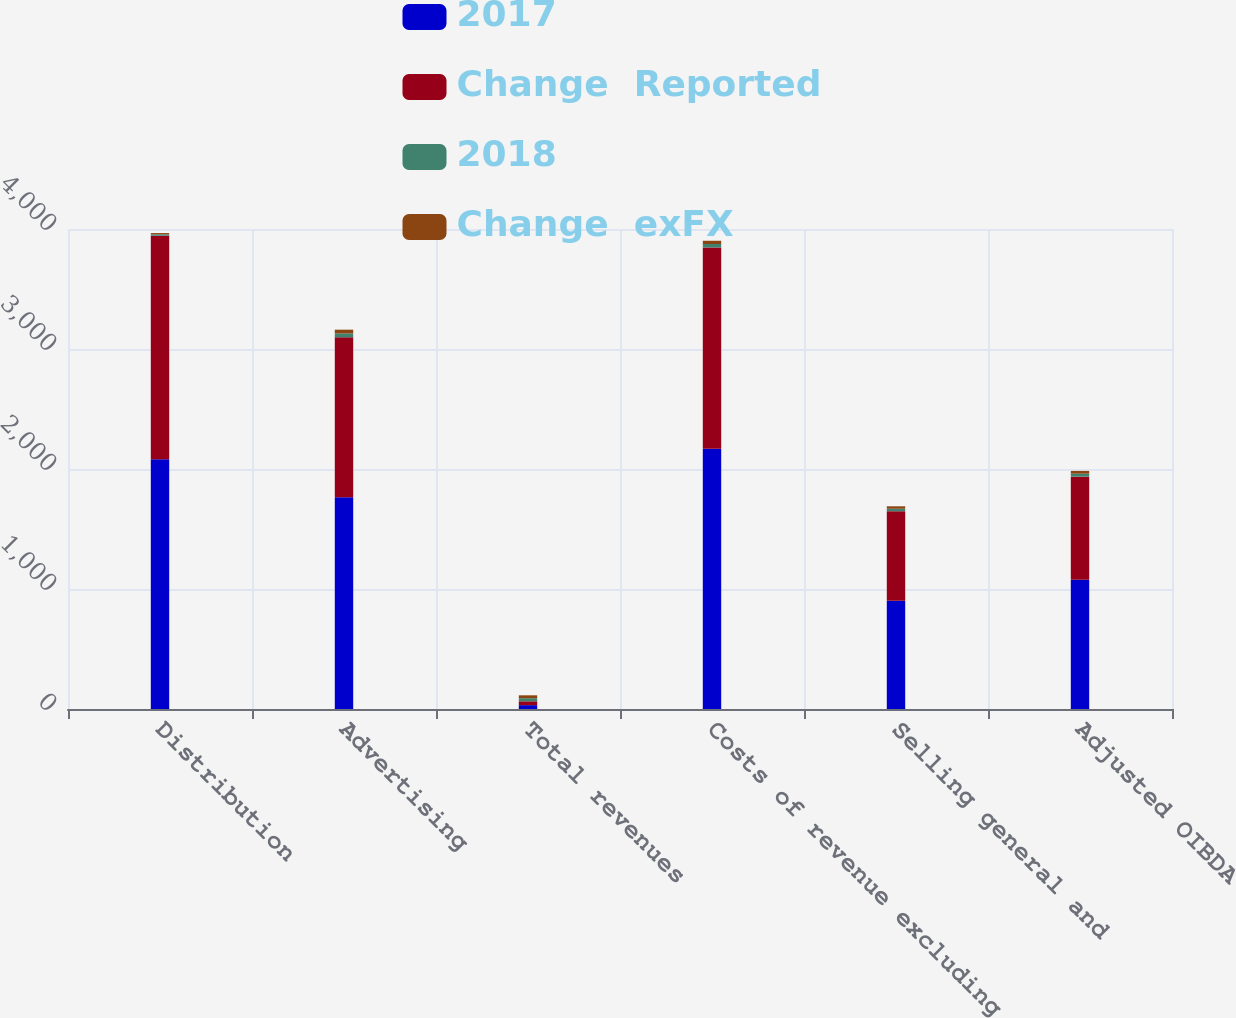Convert chart to OTSL. <chart><loc_0><loc_0><loc_500><loc_500><stacked_bar_chart><ecel><fcel>Distribution<fcel>Advertising<fcel>Total revenues<fcel>Costs of revenue excluding<fcel>Selling general and<fcel>Adjusted OIBDA<nl><fcel>2017<fcel>2082<fcel>1765<fcel>32<fcel>2169<fcel>903<fcel>1077<nl><fcel>Change  Reported<fcel>1862<fcel>1332<fcel>32<fcel>1677<fcel>745<fcel>859<nl><fcel>2018<fcel>12<fcel>33<fcel>26<fcel>29<fcel>21<fcel>25<nl><fcel>Change  exFX<fcel>10<fcel>31<fcel>24<fcel>27<fcel>20<fcel>23<nl></chart> 